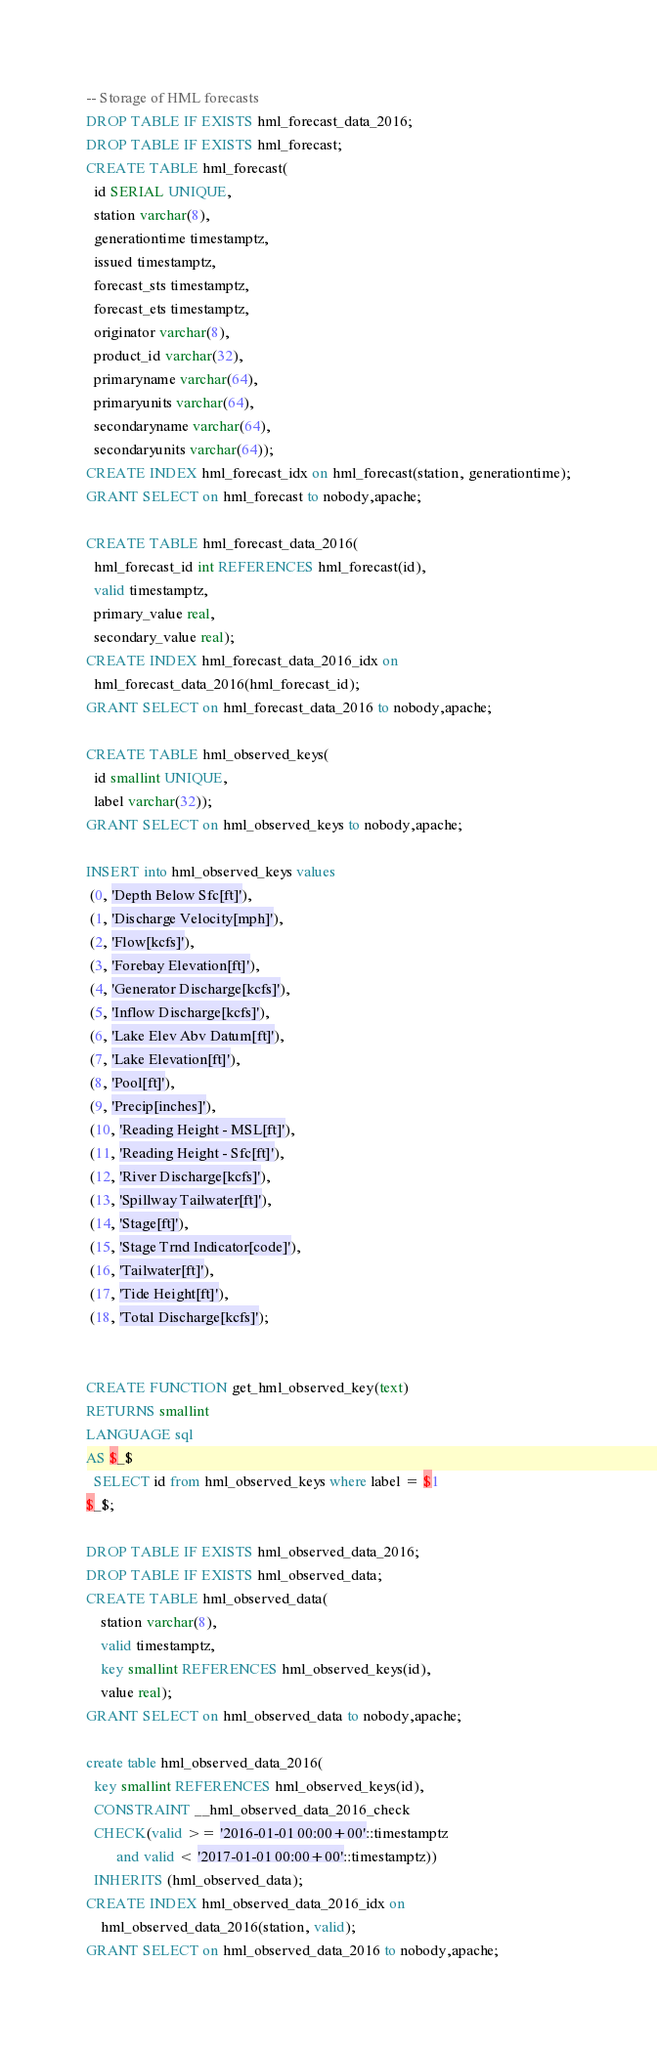Convert code to text. <code><loc_0><loc_0><loc_500><loc_500><_SQL_>-- Storage of HML forecasts
DROP TABLE IF EXISTS hml_forecast_data_2016;
DROP TABLE IF EXISTS hml_forecast;
CREATE TABLE hml_forecast(
  id SERIAL UNIQUE,
  station varchar(8),
  generationtime timestamptz,
  issued timestamptz,
  forecast_sts timestamptz,
  forecast_ets timestamptz,
  originator varchar(8),
  product_id varchar(32),
  primaryname varchar(64),
  primaryunits varchar(64),
  secondaryname varchar(64),
  secondaryunits varchar(64));
CREATE INDEX hml_forecast_idx on hml_forecast(station, generationtime);
GRANT SELECT on hml_forecast to nobody,apache;

CREATE TABLE hml_forecast_data_2016(
  hml_forecast_id int REFERENCES hml_forecast(id),
  valid timestamptz,
  primary_value real,
  secondary_value real);
CREATE INDEX hml_forecast_data_2016_idx on
  hml_forecast_data_2016(hml_forecast_id);
GRANT SELECT on hml_forecast_data_2016 to nobody,apache;

CREATE TABLE hml_observed_keys(
  id smallint UNIQUE,
  label varchar(32));
GRANT SELECT on hml_observed_keys to nobody,apache;

INSERT into hml_observed_keys values
 (0, 'Depth Below Sfc[ft]'),
 (1, 'Discharge Velocity[mph]'),
 (2, 'Flow[kcfs]'),
 (3, 'Forebay Elevation[ft]'),
 (4, 'Generator Discharge[kcfs]'),
 (5, 'Inflow Discharge[kcfs]'),
 (6, 'Lake Elev Abv Datum[ft]'),
 (7, 'Lake Elevation[ft]'),
 (8, 'Pool[ft]'),
 (9, 'Precip[inches]'),
 (10, 'Reading Height - MSL[ft]'),
 (11, 'Reading Height - Sfc[ft]'),
 (12, 'River Discharge[kcfs]'),
 (13, 'Spillway Tailwater[ft]'),
 (14, 'Stage[ft]'),
 (15, 'Stage Trnd Indicator[code]'),
 (16, 'Tailwater[ft]'),
 (17, 'Tide Height[ft]'),
 (18, 'Total Discharge[kcfs]');


CREATE FUNCTION get_hml_observed_key(text)
RETURNS smallint
LANGUAGE sql
AS $_$
  SELECT id from hml_observed_keys where label = $1
$_$;

DROP TABLE IF EXISTS hml_observed_data_2016;
DROP TABLE IF EXISTS hml_observed_data;
CREATE TABLE hml_observed_data(
	station varchar(8),
	valid timestamptz,
	key smallint REFERENCES hml_observed_keys(id),
	value real);
GRANT SELECT on hml_observed_data to nobody,apache;

create table hml_observed_data_2016(
  key smallint REFERENCES hml_observed_keys(id),
  CONSTRAINT __hml_observed_data_2016_check
  CHECK(valid >= '2016-01-01 00:00+00'::timestamptz
        and valid < '2017-01-01 00:00+00'::timestamptz))
  INHERITS (hml_observed_data);
CREATE INDEX hml_observed_data_2016_idx on
	hml_observed_data_2016(station, valid);
GRANT SELECT on hml_observed_data_2016 to nobody,apache;
</code> 